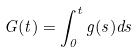<formula> <loc_0><loc_0><loc_500><loc_500>G ( t ) = \int _ { 0 } ^ { t } g ( s ) d s</formula> 